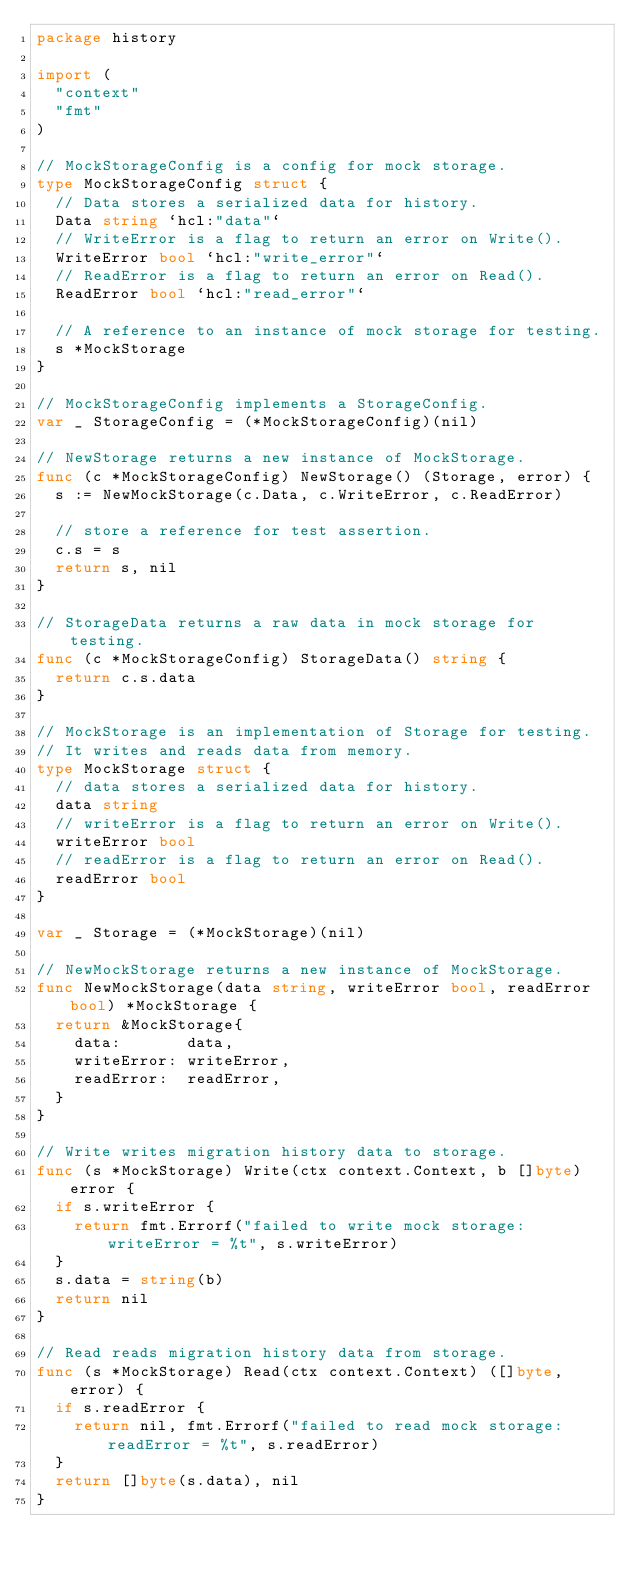Convert code to text. <code><loc_0><loc_0><loc_500><loc_500><_Go_>package history

import (
	"context"
	"fmt"
)

// MockStorageConfig is a config for mock storage.
type MockStorageConfig struct {
	// Data stores a serialized data for history.
	Data string `hcl:"data"`
	// WriteError is a flag to return an error on Write().
	WriteError bool `hcl:"write_error"`
	// ReadError is a flag to return an error on Read().
	ReadError bool `hcl:"read_error"`

	// A reference to an instance of mock storage for testing.
	s *MockStorage
}

// MockStorageConfig implements a StorageConfig.
var _ StorageConfig = (*MockStorageConfig)(nil)

// NewStorage returns a new instance of MockStorage.
func (c *MockStorageConfig) NewStorage() (Storage, error) {
	s := NewMockStorage(c.Data, c.WriteError, c.ReadError)

	// store a reference for test assertion.
	c.s = s
	return s, nil
}

// StorageData returns a raw data in mock storage for testing.
func (c *MockStorageConfig) StorageData() string {
	return c.s.data
}

// MockStorage is an implementation of Storage for testing.
// It writes and reads data from memory.
type MockStorage struct {
	// data stores a serialized data for history.
	data string
	// writeError is a flag to return an error on Write().
	writeError bool
	// readError is a flag to return an error on Read().
	readError bool
}

var _ Storage = (*MockStorage)(nil)

// NewMockStorage returns a new instance of MockStorage.
func NewMockStorage(data string, writeError bool, readError bool) *MockStorage {
	return &MockStorage{
		data:       data,
		writeError: writeError,
		readError:  readError,
	}
}

// Write writes migration history data to storage.
func (s *MockStorage) Write(ctx context.Context, b []byte) error {
	if s.writeError {
		return fmt.Errorf("failed to write mock storage: writeError = %t", s.writeError)
	}
	s.data = string(b)
	return nil
}

// Read reads migration history data from storage.
func (s *MockStorage) Read(ctx context.Context) ([]byte, error) {
	if s.readError {
		return nil, fmt.Errorf("failed to read mock storage: readError = %t", s.readError)
	}
	return []byte(s.data), nil
}
</code> 